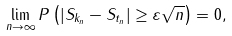Convert formula to latex. <formula><loc_0><loc_0><loc_500><loc_500>\lim _ { n \to \infty } P \left ( | S _ { k _ { n } } - S _ { t _ { n } } | \geq \varepsilon \sqrt { n } \right ) = 0 ,</formula> 